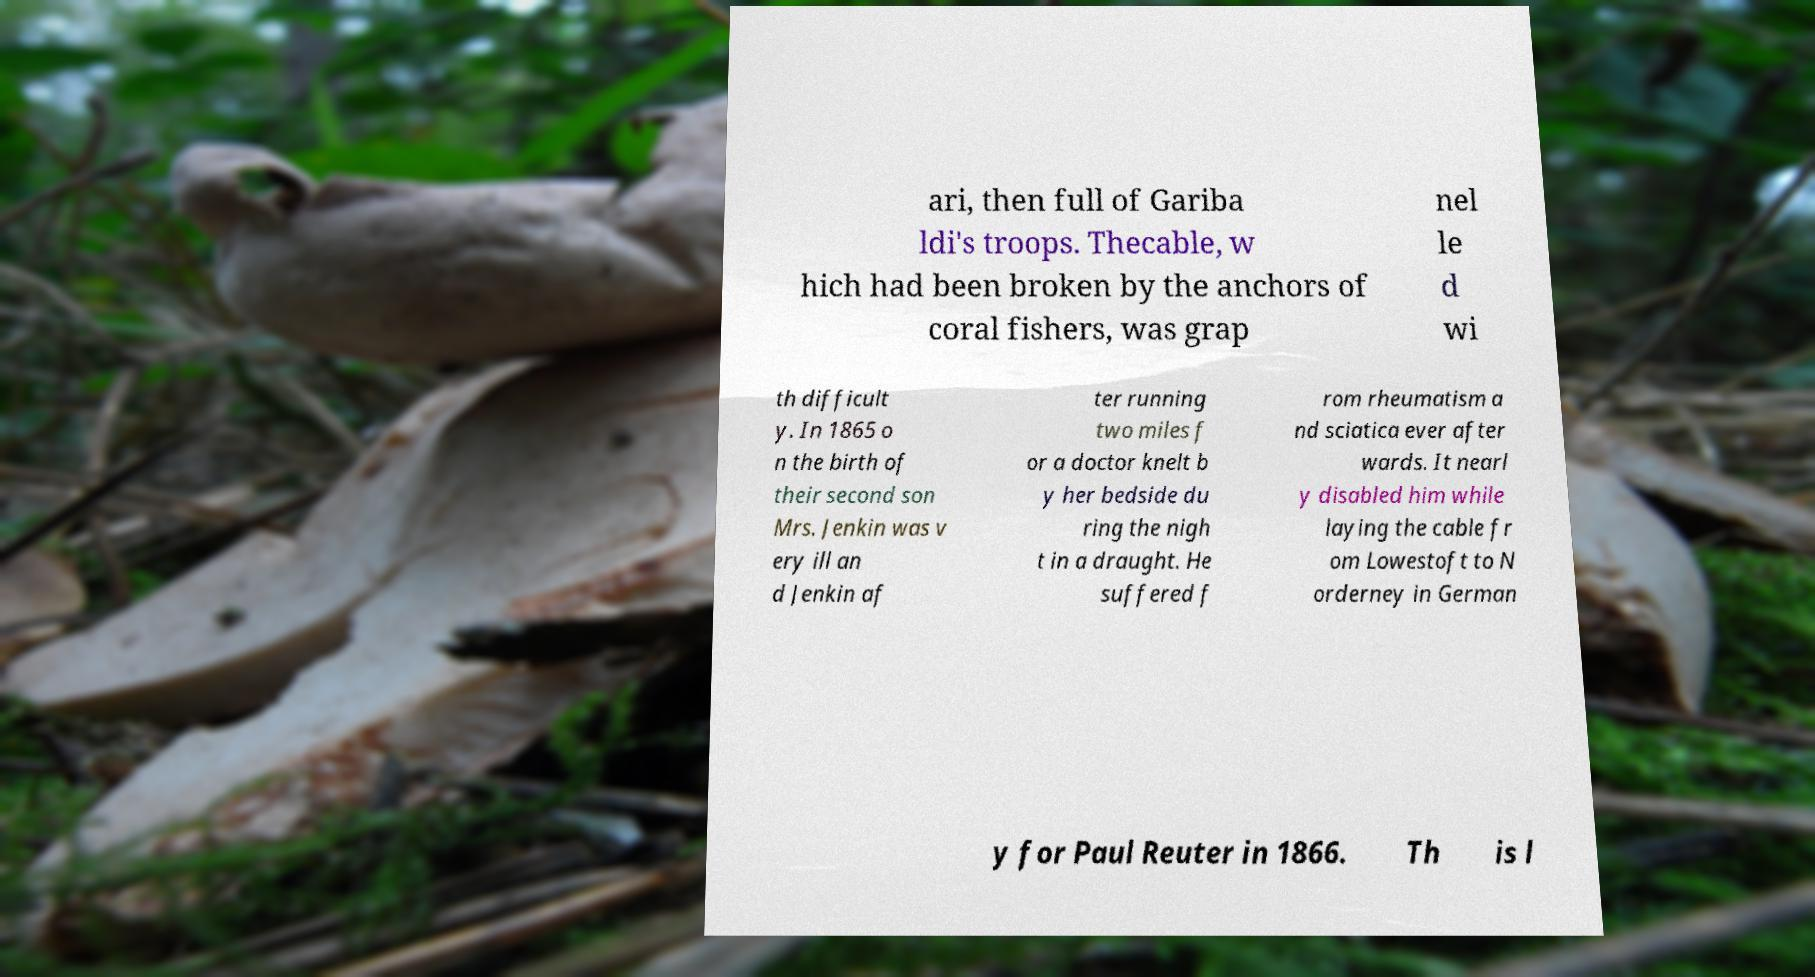There's text embedded in this image that I need extracted. Can you transcribe it verbatim? ari, then full of Gariba ldi's troops. Thecable, w hich had been broken by the anchors of coral fishers, was grap nel le d wi th difficult y. In 1865 o n the birth of their second son Mrs. Jenkin was v ery ill an d Jenkin af ter running two miles f or a doctor knelt b y her bedside du ring the nigh t in a draught. He suffered f rom rheumatism a nd sciatica ever after wards. It nearl y disabled him while laying the cable fr om Lowestoft to N orderney in German y for Paul Reuter in 1866. Th is l 